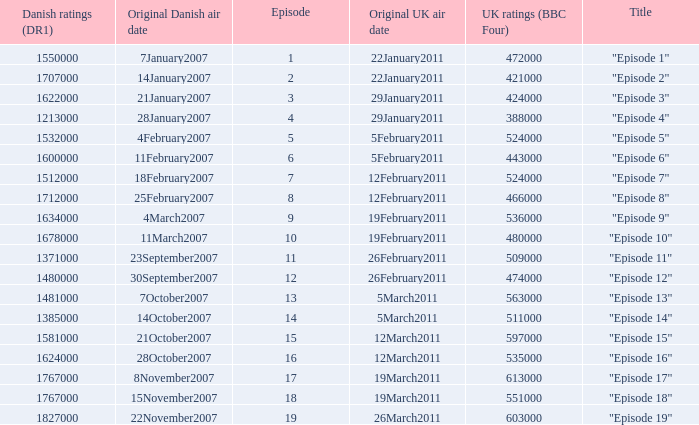What were the UK ratings (BBC Four) for "Episode 17"?  613000.0. 